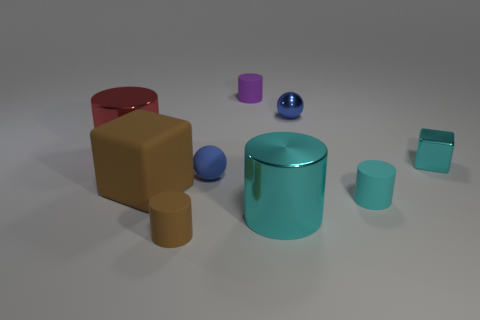Are there any blue rubber balls on the left side of the blue rubber object?
Ensure brevity in your answer.  No. Do the small purple cylinder and the large cylinder that is left of the brown matte cube have the same material?
Offer a very short reply. No. There is a cyan shiny object that is right of the tiny cyan matte cylinder; is its shape the same as the small blue rubber object?
Your response must be concise. No. What number of small cyan cylinders have the same material as the brown block?
Offer a very short reply. 1. How many objects are objects left of the tiny brown matte cylinder or blue rubber cylinders?
Ensure brevity in your answer.  2. What is the size of the cyan metallic cube?
Give a very brief answer. Small. What is the big cyan cylinder that is in front of the blue ball that is to the right of the tiny blue rubber ball made of?
Your response must be concise. Metal. Does the metallic cylinder that is behind the cyan cube have the same size as the cyan cube?
Ensure brevity in your answer.  No. Are there any spheres that have the same color as the metal cube?
Provide a short and direct response. No. How many things are either objects that are behind the tiny brown cylinder or blue balls in front of the blue shiny object?
Give a very brief answer. 8. 